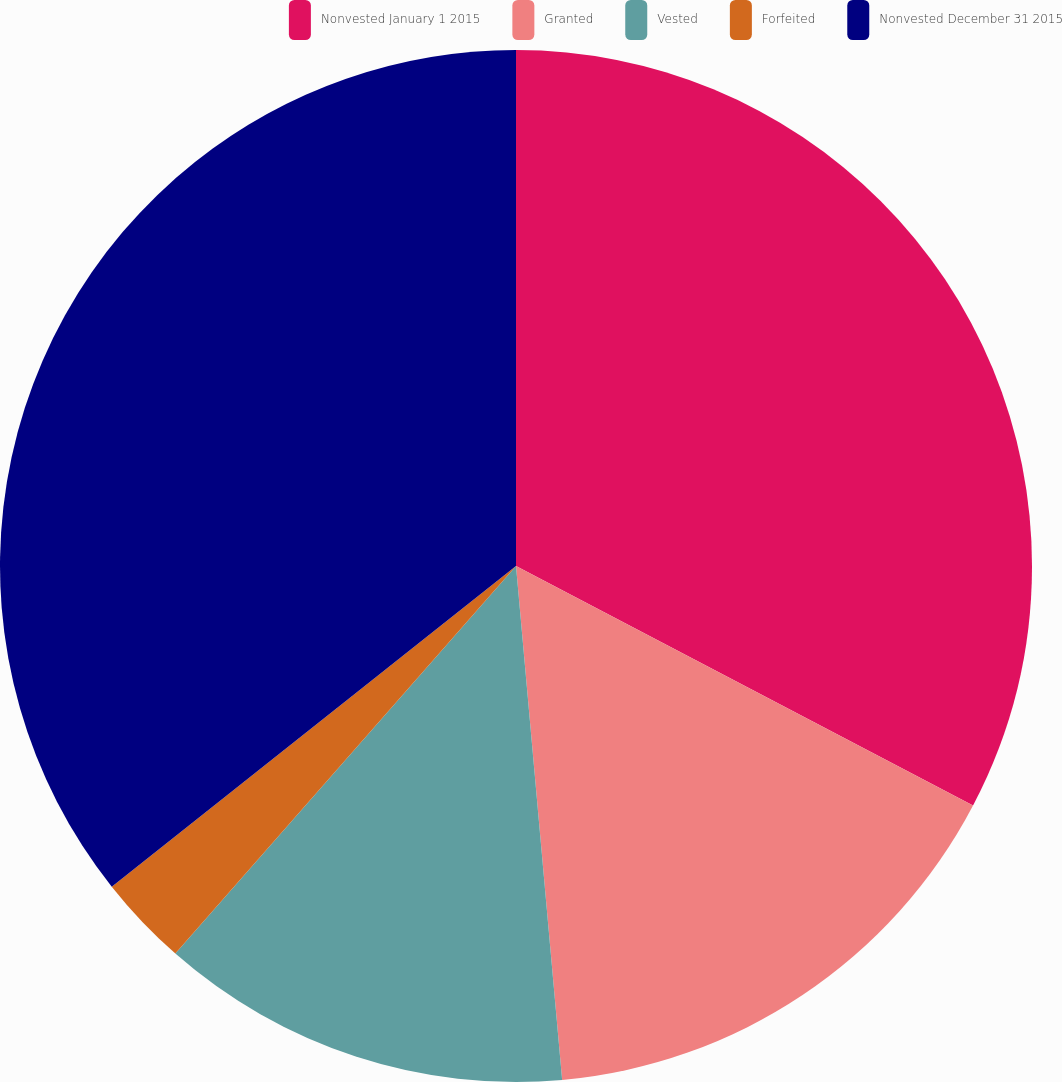<chart> <loc_0><loc_0><loc_500><loc_500><pie_chart><fcel>Nonvested January 1 2015<fcel>Granted<fcel>Vested<fcel>Forfeited<fcel>Nonvested December 31 2015<nl><fcel>32.68%<fcel>15.89%<fcel>12.9%<fcel>2.85%<fcel>35.67%<nl></chart> 